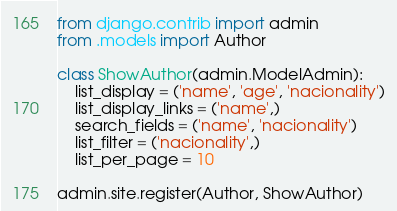<code> <loc_0><loc_0><loc_500><loc_500><_Python_>from django.contrib import admin
from .models import Author

class ShowAuthor(admin.ModelAdmin):
    list_display = ('name', 'age', 'nacionality')
    list_display_links = ('name',)
    search_fields = ('name', 'nacionality')
    list_filter = ('nacionality',)
    list_per_page = 10

admin.site.register(Author, ShowAuthor)
</code> 